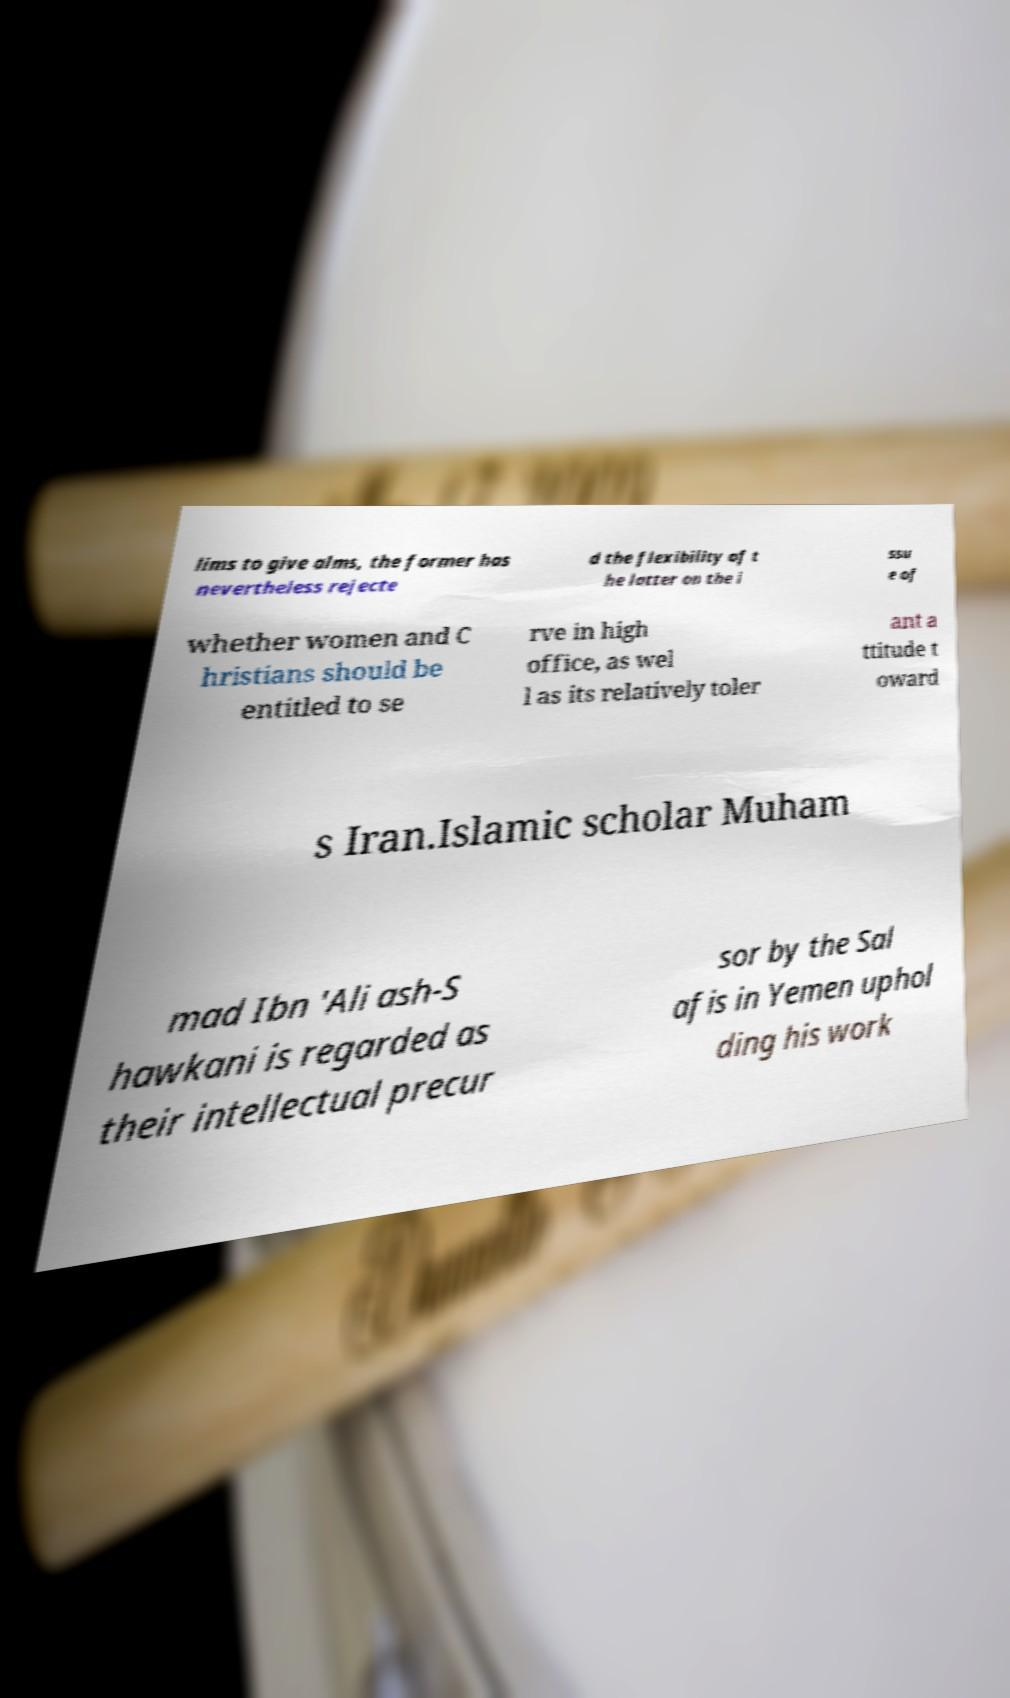Could you extract and type out the text from this image? lims to give alms, the former has nevertheless rejecte d the flexibility of t he latter on the i ssu e of whether women and C hristians should be entitled to se rve in high office, as wel l as its relatively toler ant a ttitude t oward s Iran.Islamic scholar Muham mad Ibn 'Ali ash-S hawkani is regarded as their intellectual precur sor by the Sal afis in Yemen uphol ding his work 